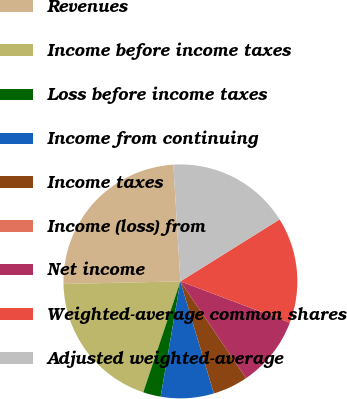Convert chart. <chart><loc_0><loc_0><loc_500><loc_500><pie_chart><fcel>Revenues<fcel>Income before income taxes<fcel>Loss before income taxes<fcel>Income from continuing<fcel>Income taxes<fcel>Income (loss) from<fcel>Net income<fcel>Weighted-average common shares<fcel>Adjusted weighted-average<nl><fcel>24.39%<fcel>19.51%<fcel>2.44%<fcel>7.32%<fcel>4.88%<fcel>0.0%<fcel>9.76%<fcel>14.63%<fcel>17.07%<nl></chart> 